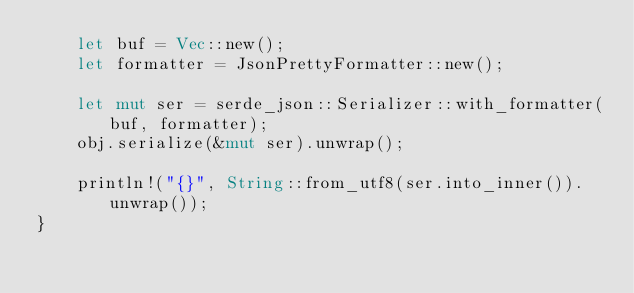Convert code to text. <code><loc_0><loc_0><loc_500><loc_500><_Rust_>    let buf = Vec::new();
    let formatter = JsonPrettyFormatter::new();

    let mut ser = serde_json::Serializer::with_formatter(buf, formatter);
    obj.serialize(&mut ser).unwrap();

    println!("{}", String::from_utf8(ser.into_inner()).unwrap());
}</code> 